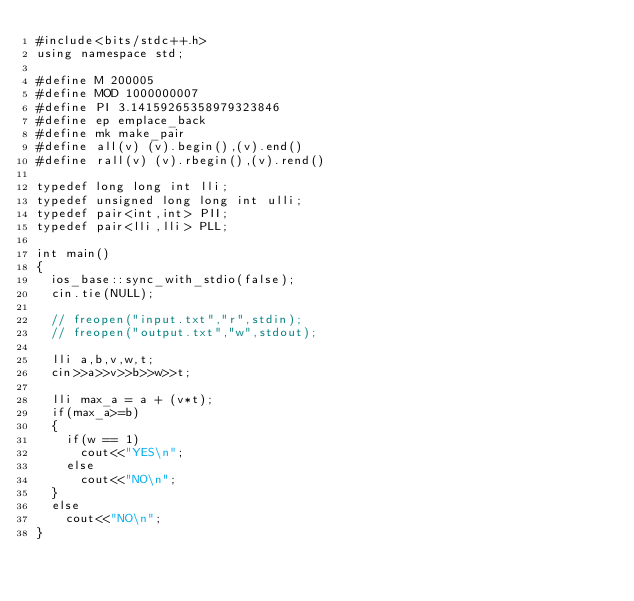Convert code to text. <code><loc_0><loc_0><loc_500><loc_500><_C++_>#include<bits/stdc++.h>
using namespace std;

#define M 200005
#define MOD 1000000007
#define PI 3.14159265358979323846
#define ep emplace_back
#define mk make_pair
#define all(v) (v).begin(),(v).end()
#define rall(v) (v).rbegin(),(v).rend()

typedef long long int lli;
typedef unsigned long long int ulli;
typedef pair<int,int> PII;
typedef pair<lli,lli> PLL;

int main()
{
	ios_base::sync_with_stdio(false);
	cin.tie(NULL);

	// freopen("input.txt","r",stdin);
	// freopen("output.txt","w",stdout);

	lli a,b,v,w,t;
	cin>>a>>v>>b>>w>>t;

	lli max_a = a + (v*t);
	if(max_a>=b)
	{
		if(w == 1)
			cout<<"YES\n";
		else
			cout<<"NO\n";
	}		
	else
		cout<<"NO\n";
}</code> 